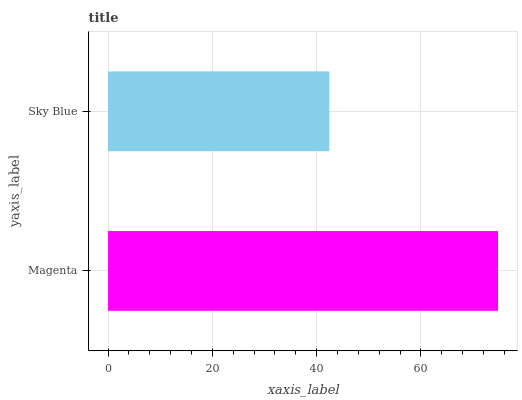Is Sky Blue the minimum?
Answer yes or no. Yes. Is Magenta the maximum?
Answer yes or no. Yes. Is Sky Blue the maximum?
Answer yes or no. No. Is Magenta greater than Sky Blue?
Answer yes or no. Yes. Is Sky Blue less than Magenta?
Answer yes or no. Yes. Is Sky Blue greater than Magenta?
Answer yes or no. No. Is Magenta less than Sky Blue?
Answer yes or no. No. Is Magenta the high median?
Answer yes or no. Yes. Is Sky Blue the low median?
Answer yes or no. Yes. Is Sky Blue the high median?
Answer yes or no. No. Is Magenta the low median?
Answer yes or no. No. 